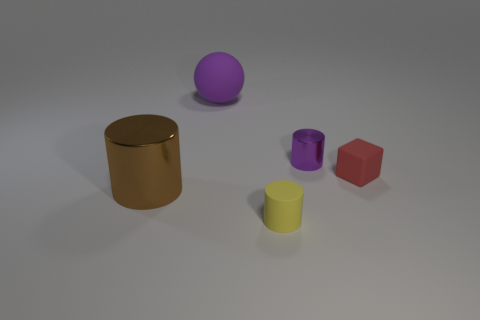How many small things are purple objects or matte cylinders?
Provide a succinct answer. 2. Is the number of small objects that are in front of the tiny purple shiny thing the same as the number of metallic objects?
Make the answer very short. Yes. Is there a purple cylinder to the right of the cylinder in front of the large brown metallic cylinder?
Make the answer very short. Yes. What number of other things are there of the same color as the tiny shiny thing?
Your answer should be compact. 1. The cube is what color?
Your answer should be very brief. Red. How big is the rubber thing that is in front of the large rubber object and behind the small yellow object?
Provide a succinct answer. Small. How many objects are metal cylinders to the right of the purple ball or large purple rubber things?
Provide a succinct answer. 2. The large object that is the same material as the small purple cylinder is what shape?
Your response must be concise. Cylinder. What shape is the tiny purple shiny thing?
Your answer should be compact. Cylinder. There is a cylinder that is both on the right side of the brown cylinder and behind the yellow cylinder; what color is it?
Provide a succinct answer. Purple. 